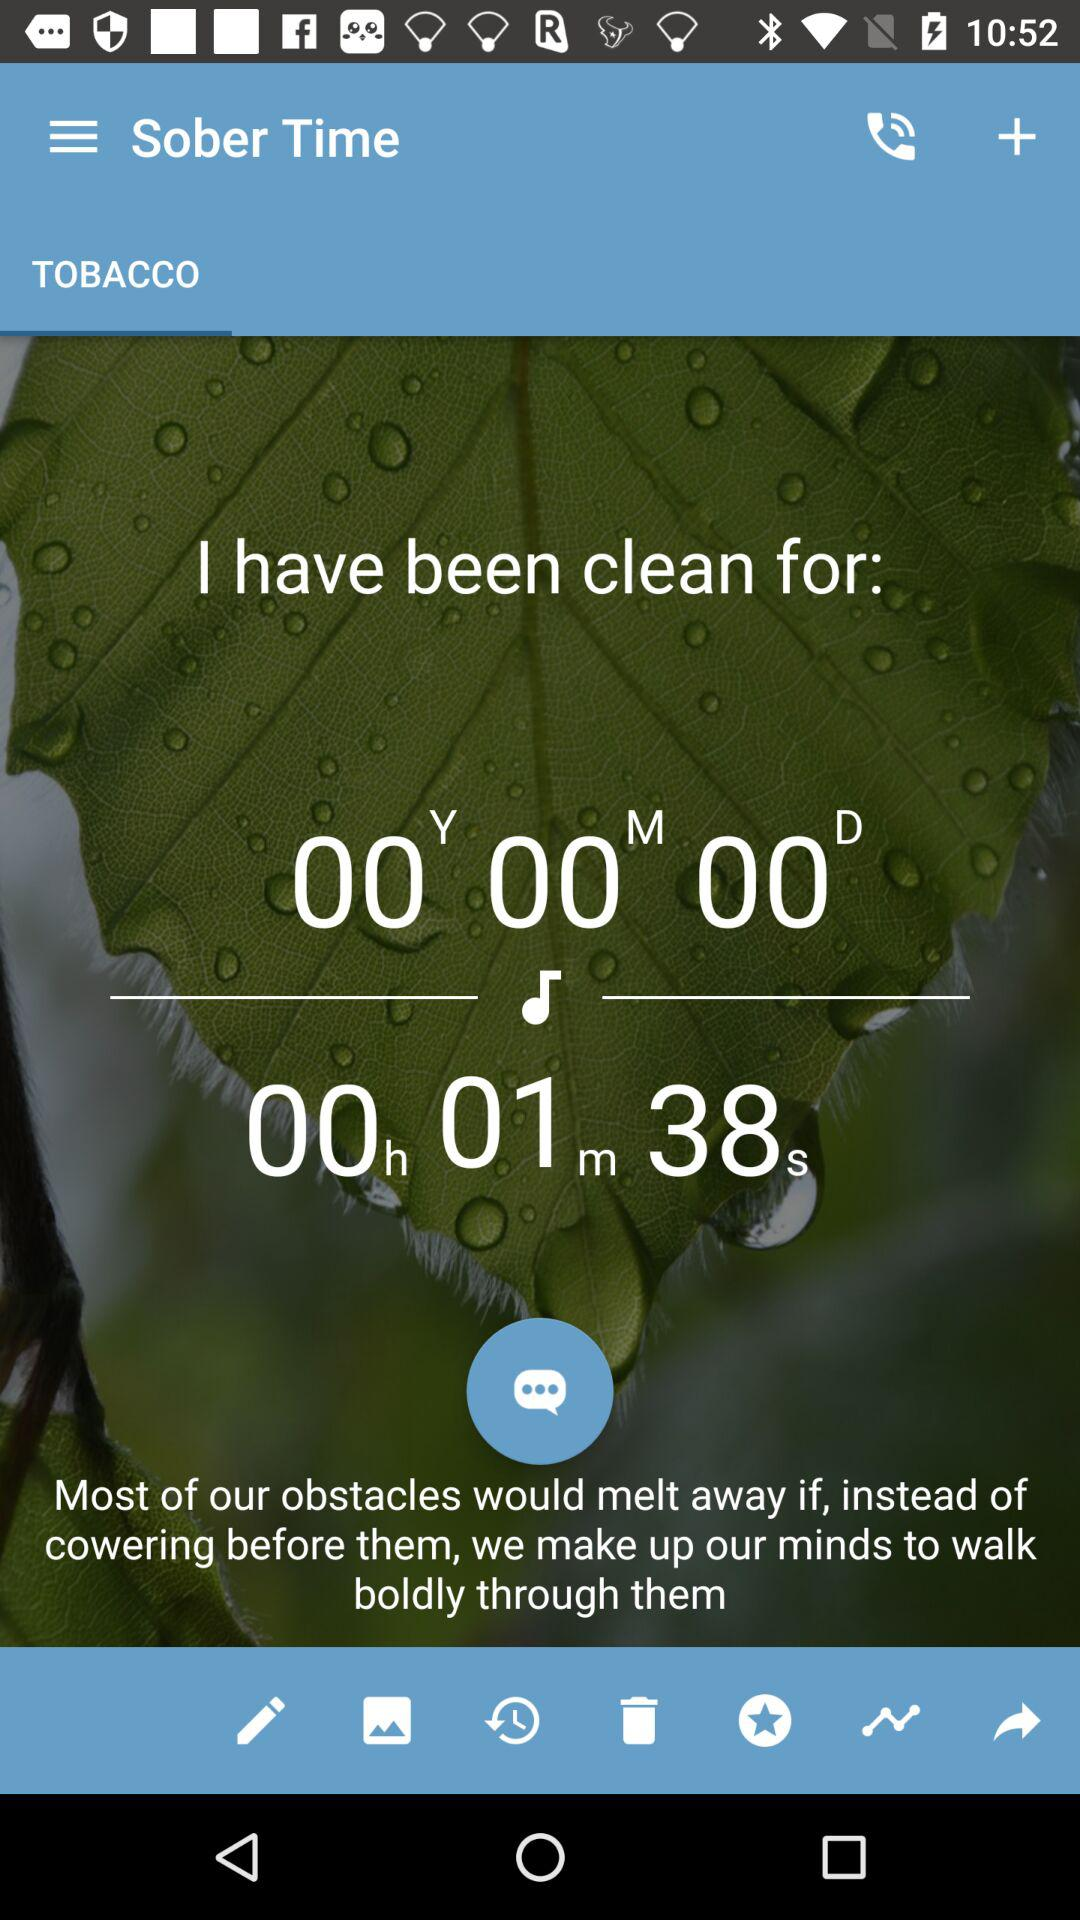How much time has passed? The passed time is 1 minute 38 seconds. 